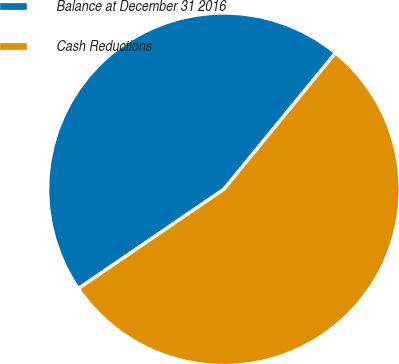Convert chart. <chart><loc_0><loc_0><loc_500><loc_500><pie_chart><fcel>Balance at December 31 2016<fcel>Cash Reductions<nl><fcel>45.45%<fcel>54.55%<nl></chart> 